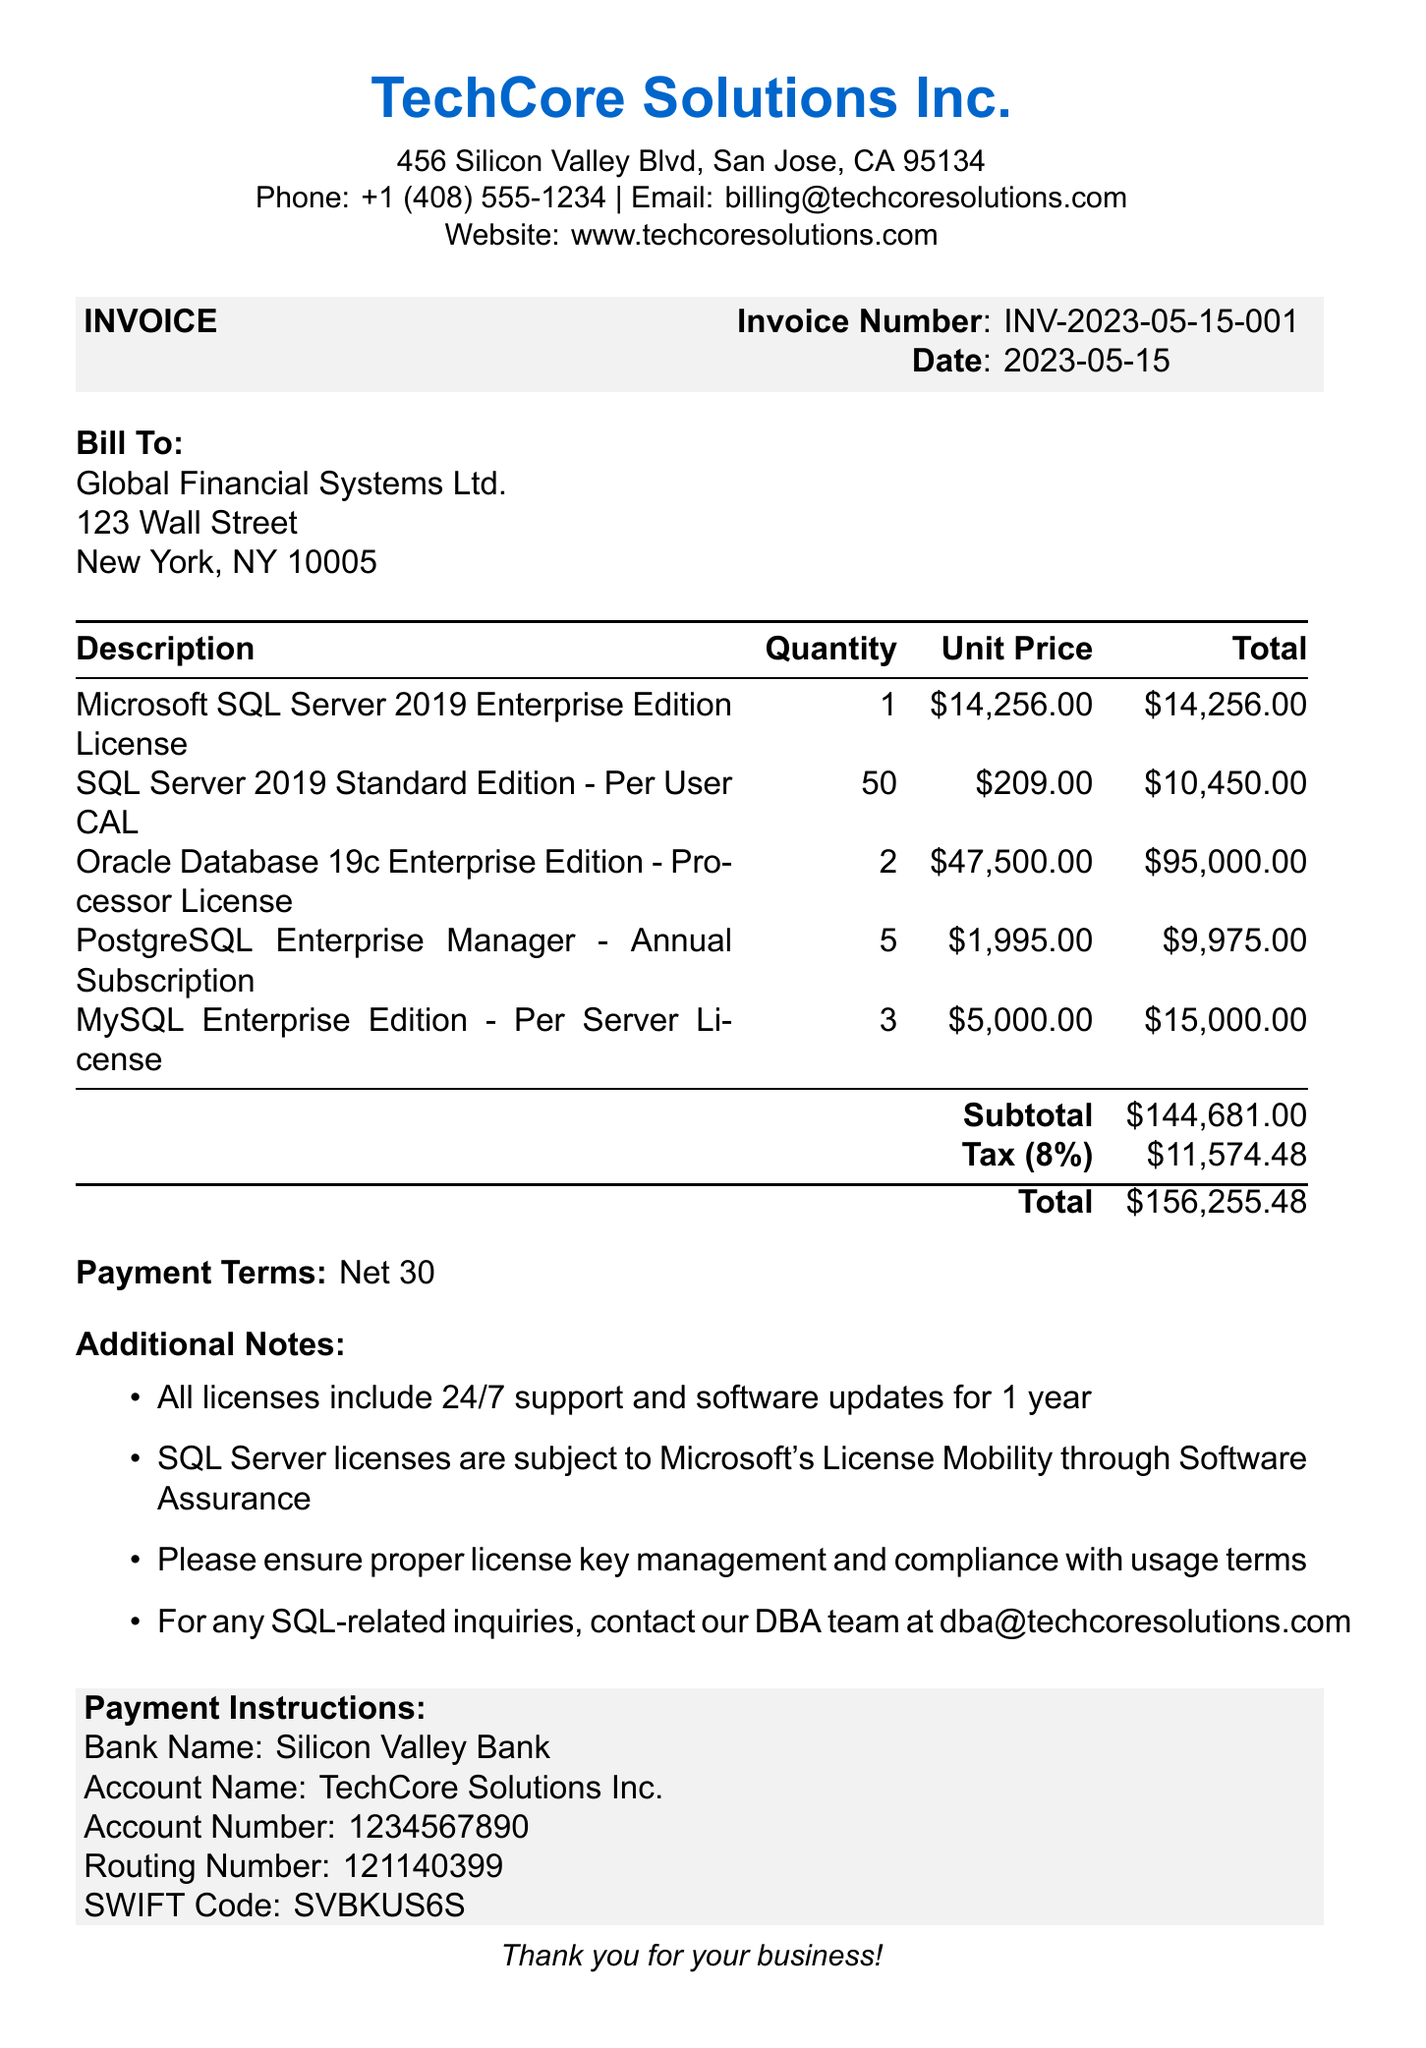what is the invoice number? The invoice number is clearly stated at the top of the document, which is INV-2023-05-15-001.
Answer: INV-2023-05-15-001 who is the client? The document specifies the client under the 'Bill To' section, which is Global Financial Systems Ltd.
Answer: Global Financial Systems Ltd what is the total amount due? The total amount due is shown at the bottom of the invoice, which sums up to $156,255.48.
Answer: $156,255.48 how many SQL Server 2019 Standard Edition licenses were purchased? The quantity of SQL Server 2019 Standard Edition licenses can be found in the item table, which lists 50.
Answer: 50 what is the tax rate applied? The document notes the tax rate applied, which is 8%.
Answer: 8% how much is the subtotal before tax? The subtotal before tax is provided in the invoice and is stated as $144,681.00.
Answer: $144,681.00 what kind of payment terms are listed? The payment terms are explicitly mentioned as 'Net 30' within the document.
Answer: Net 30 what additional support is included with the licenses? The additional note states that all licenses include 24/7 support and software updates for 1 year.
Answer: 24/7 support and software updates for 1 year how many licenses were purchased for the Oracle Database? The quantity for Oracle Database licenses is detailed in the items list, which shows 2.
Answer: 2 